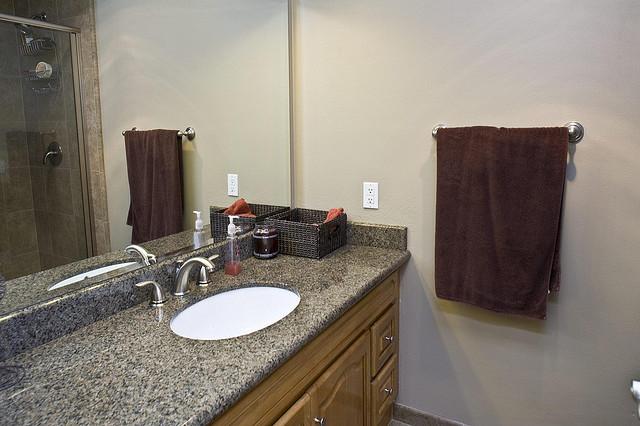Is the bottle of hand soap full?
Give a very brief answer. No. What type of wall covering is there?
Write a very short answer. Paint. Is there a towel on the rack?
Answer briefly. Yes. What is in the picture?
Quick response, please. Bathroom. 